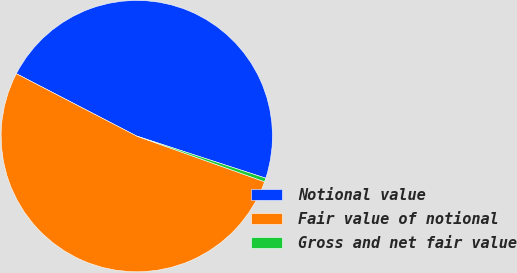Convert chart to OTSL. <chart><loc_0><loc_0><loc_500><loc_500><pie_chart><fcel>Notional value<fcel>Fair value of notional<fcel>Gross and net fair value<nl><fcel>47.41%<fcel>52.15%<fcel>0.44%<nl></chart> 